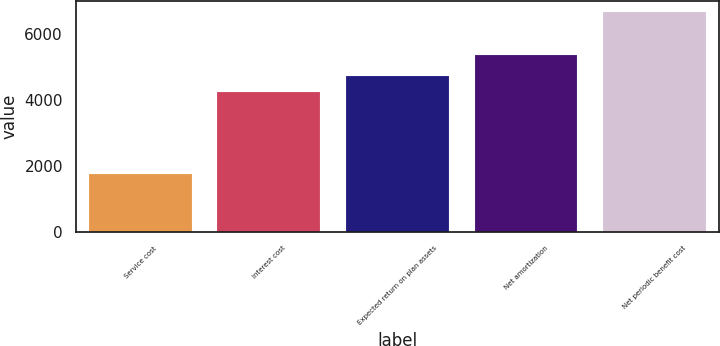<chart> <loc_0><loc_0><loc_500><loc_500><bar_chart><fcel>Service cost<fcel>Interest cost<fcel>Expected return on plan assets<fcel>Net amortization<fcel>Net periodic benefit cost<nl><fcel>1756<fcel>4247<fcel>4740.6<fcel>5376<fcel>6692<nl></chart> 